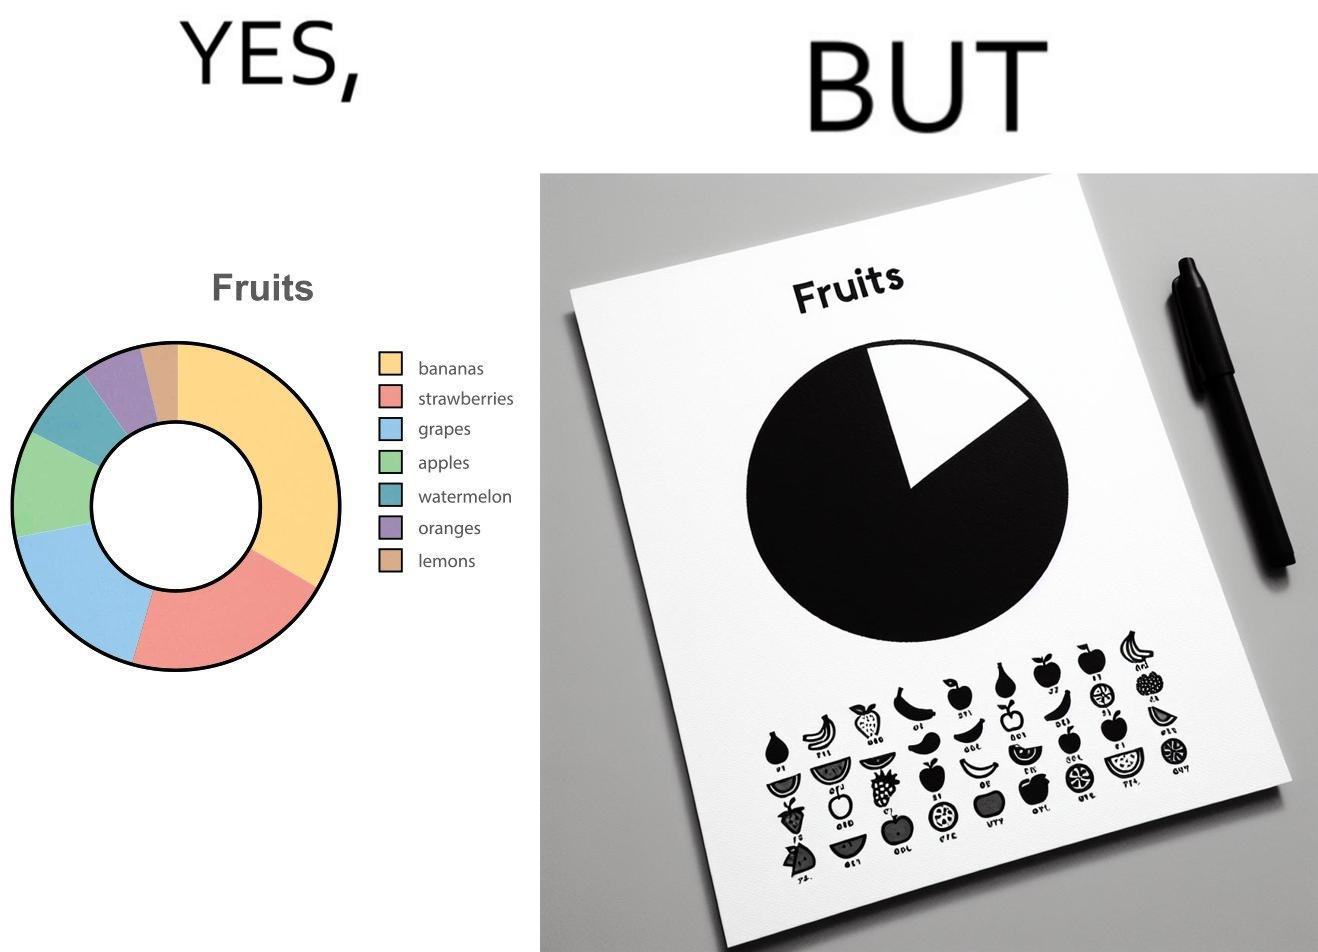Describe the contrast between the left and right parts of this image. In the left part of the image: A colorful pie chart titled "Fruits", with different distributions of various fruits like bananas, strawberries, grapes, apples, watermelon, oranges and lemons. In the right part of the image: A BLACK and WHITE greyscale printout of a pie chart titled "Fruits". The pie chart is just one circle with no divisions, but there is a key beside it that mentions various fruits like bananas, strawberries, grapes, apples, watermelon, oranges and lemons. 